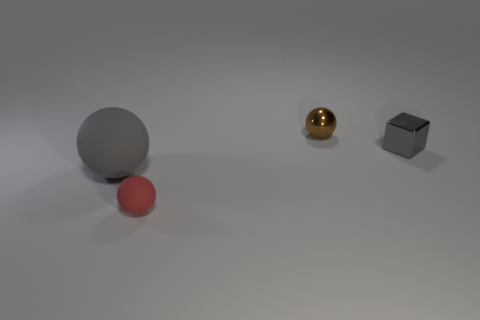Add 2 tiny red matte balls. How many objects exist? 6 Subtract all cubes. How many objects are left? 3 Subtract 0 yellow cubes. How many objects are left? 4 Subtract all tiny matte balls. Subtract all red rubber balls. How many objects are left? 2 Add 1 tiny red spheres. How many tiny red spheres are left? 2 Add 3 blue cubes. How many blue cubes exist? 3 